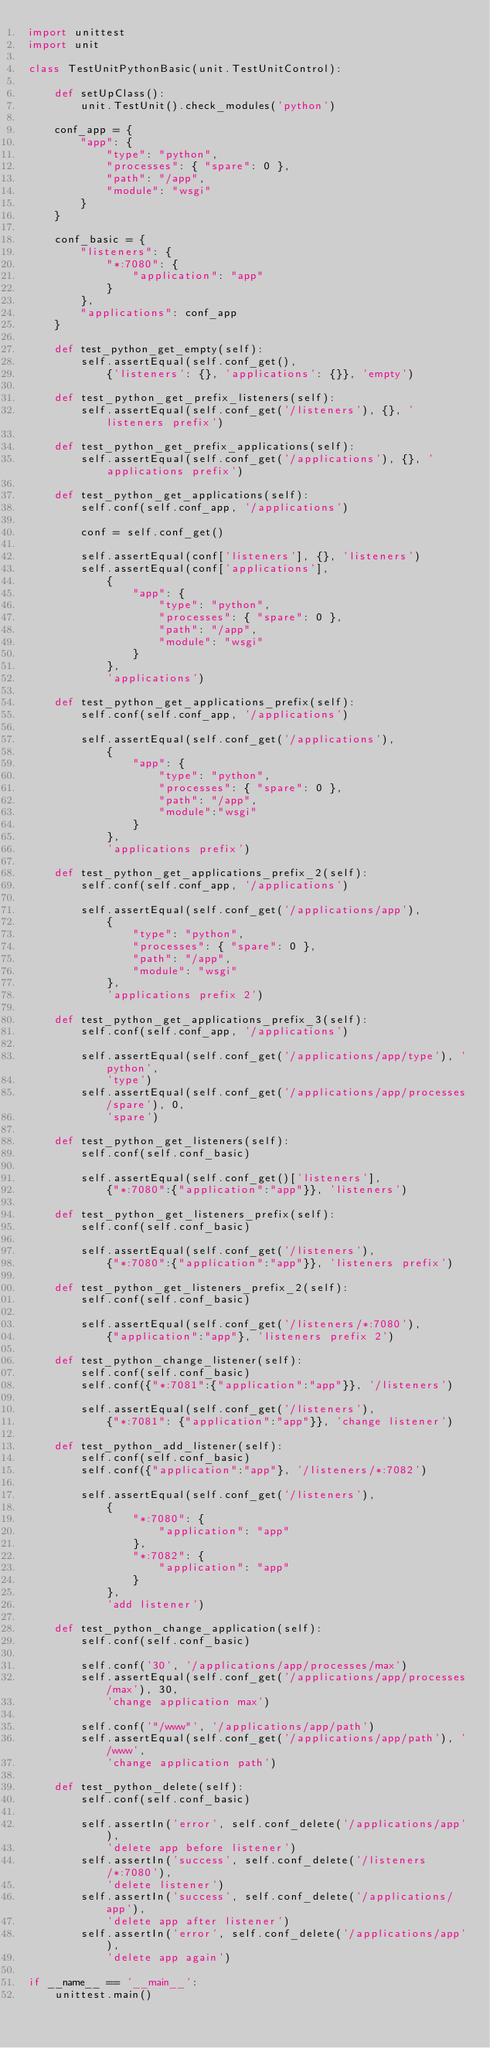<code> <loc_0><loc_0><loc_500><loc_500><_Python_>import unittest
import unit

class TestUnitPythonBasic(unit.TestUnitControl):

    def setUpClass():
        unit.TestUnit().check_modules('python')

    conf_app = {
        "app": {
            "type": "python",
            "processes": { "spare": 0 },
            "path": "/app",
            "module": "wsgi"
        }
    }

    conf_basic = {
        "listeners": {
            "*:7080": {
                "application": "app"
            }
        },
        "applications": conf_app
    }

    def test_python_get_empty(self):
        self.assertEqual(self.conf_get(),
            {'listeners': {}, 'applications': {}}, 'empty')

    def test_python_get_prefix_listeners(self):
        self.assertEqual(self.conf_get('/listeners'), {}, 'listeners prefix')

    def test_python_get_prefix_applications(self):
        self.assertEqual(self.conf_get('/applications'), {}, 'applications prefix')

    def test_python_get_applications(self):
        self.conf(self.conf_app, '/applications')

        conf = self.conf_get()

        self.assertEqual(conf['listeners'], {}, 'listeners')
        self.assertEqual(conf['applications'],
            {
                "app": {
                    "type": "python",
                    "processes": { "spare": 0 },
                    "path": "/app",
                    "module": "wsgi"
                }
            },
            'applications')

    def test_python_get_applications_prefix(self):
        self.conf(self.conf_app, '/applications')

        self.assertEqual(self.conf_get('/applications'),
            {
                "app": {
                    "type": "python",
                    "processes": { "spare": 0 },
                    "path": "/app",
                    "module":"wsgi"
                }
            },
            'applications prefix')

    def test_python_get_applications_prefix_2(self):
        self.conf(self.conf_app, '/applications')

        self.assertEqual(self.conf_get('/applications/app'),
            {
                "type": "python",
                "processes": { "spare": 0 },
                "path": "/app",
                "module": "wsgi"
            },
            'applications prefix 2')

    def test_python_get_applications_prefix_3(self):
        self.conf(self.conf_app, '/applications')

        self.assertEqual(self.conf_get('/applications/app/type'), 'python',
            'type')
        self.assertEqual(self.conf_get('/applications/app/processes/spare'), 0,
            'spare')

    def test_python_get_listeners(self):
        self.conf(self.conf_basic)

        self.assertEqual(self.conf_get()['listeners'],
            {"*:7080":{"application":"app"}}, 'listeners')

    def test_python_get_listeners_prefix(self):
        self.conf(self.conf_basic)

        self.assertEqual(self.conf_get('/listeners'),
            {"*:7080":{"application":"app"}}, 'listeners prefix')

    def test_python_get_listeners_prefix_2(self):
        self.conf(self.conf_basic)

        self.assertEqual(self.conf_get('/listeners/*:7080'),
            {"application":"app"}, 'listeners prefix 2')

    def test_python_change_listener(self):
        self.conf(self.conf_basic)
        self.conf({"*:7081":{"application":"app"}}, '/listeners')

        self.assertEqual(self.conf_get('/listeners'),
            {"*:7081": {"application":"app"}}, 'change listener')

    def test_python_add_listener(self):
        self.conf(self.conf_basic)
        self.conf({"application":"app"}, '/listeners/*:7082')

        self.assertEqual(self.conf_get('/listeners'),
            {
                "*:7080": {
                    "application": "app"
                },
                "*:7082": {
                    "application": "app"
                }
            },
            'add listener')

    def test_python_change_application(self):
        self.conf(self.conf_basic)

        self.conf('30', '/applications/app/processes/max')
        self.assertEqual(self.conf_get('/applications/app/processes/max'), 30,
            'change application max')

        self.conf('"/www"', '/applications/app/path')
        self.assertEqual(self.conf_get('/applications/app/path'), '/www',
            'change application path')

    def test_python_delete(self):
        self.conf(self.conf_basic)

        self.assertIn('error', self.conf_delete('/applications/app'),
            'delete app before listener')
        self.assertIn('success', self.conf_delete('/listeners/*:7080'),
            'delete listener')
        self.assertIn('success', self.conf_delete('/applications/app'),
            'delete app after listener')
        self.assertIn('error', self.conf_delete('/applications/app'),
            'delete app again')

if __name__ == '__main__':
    unittest.main()
</code> 